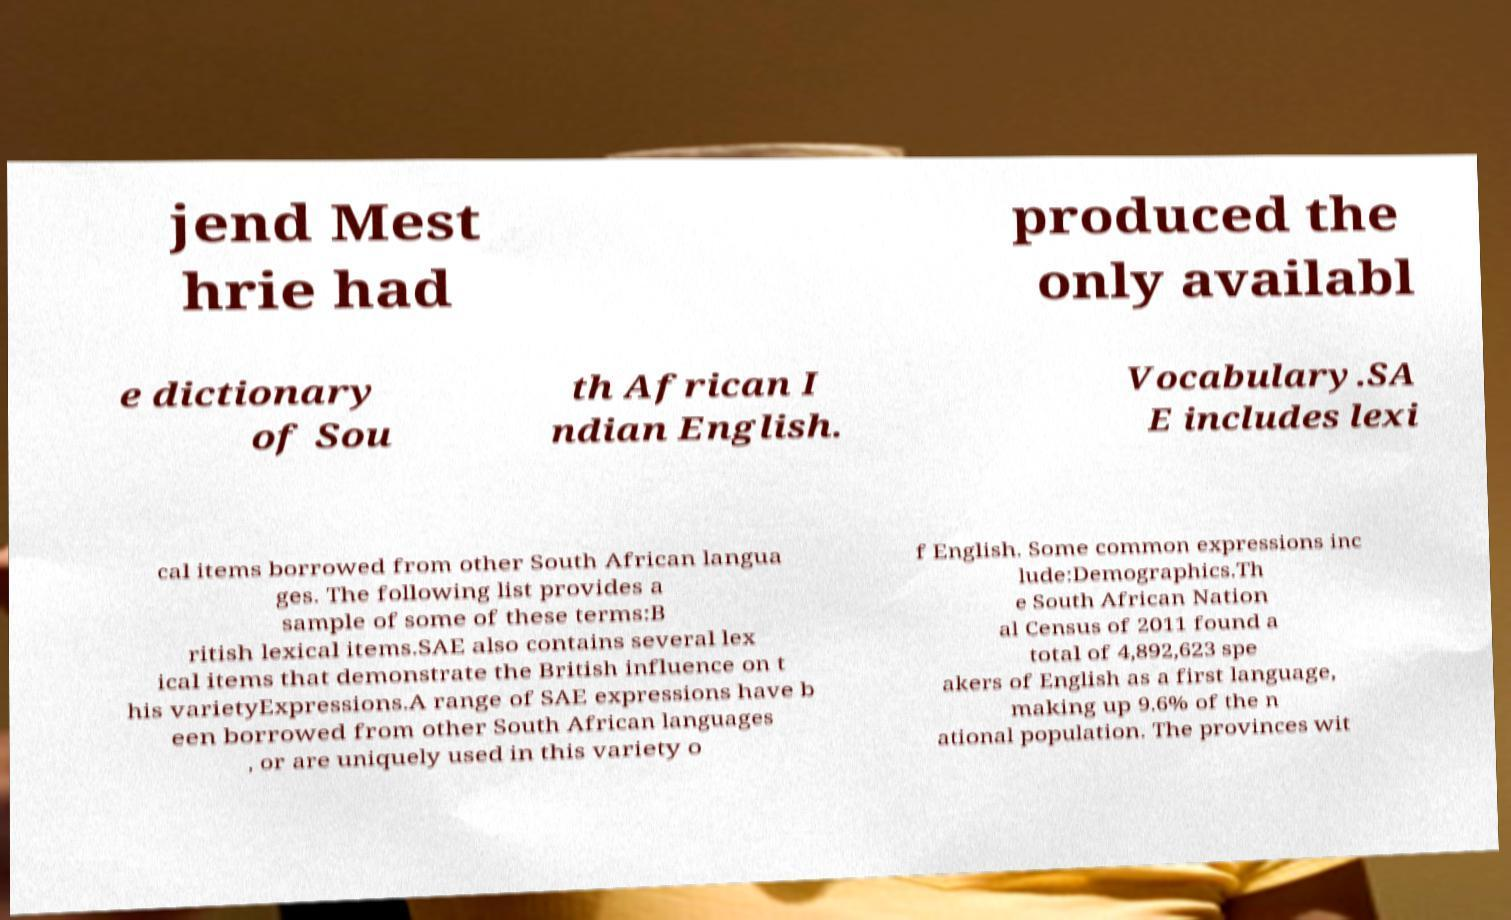For documentation purposes, I need the text within this image transcribed. Could you provide that? jend Mest hrie had produced the only availabl e dictionary of Sou th African I ndian English. Vocabulary.SA E includes lexi cal items borrowed from other South African langua ges. The following list provides a sample of some of these terms:B ritish lexical items.SAE also contains several lex ical items that demonstrate the British influence on t his varietyExpressions.A range of SAE expressions have b een borrowed from other South African languages , or are uniquely used in this variety o f English. Some common expressions inc lude:Demographics.Th e South African Nation al Census of 2011 found a total of 4,892,623 spe akers of English as a first language, making up 9.6% of the n ational population. The provinces wit 